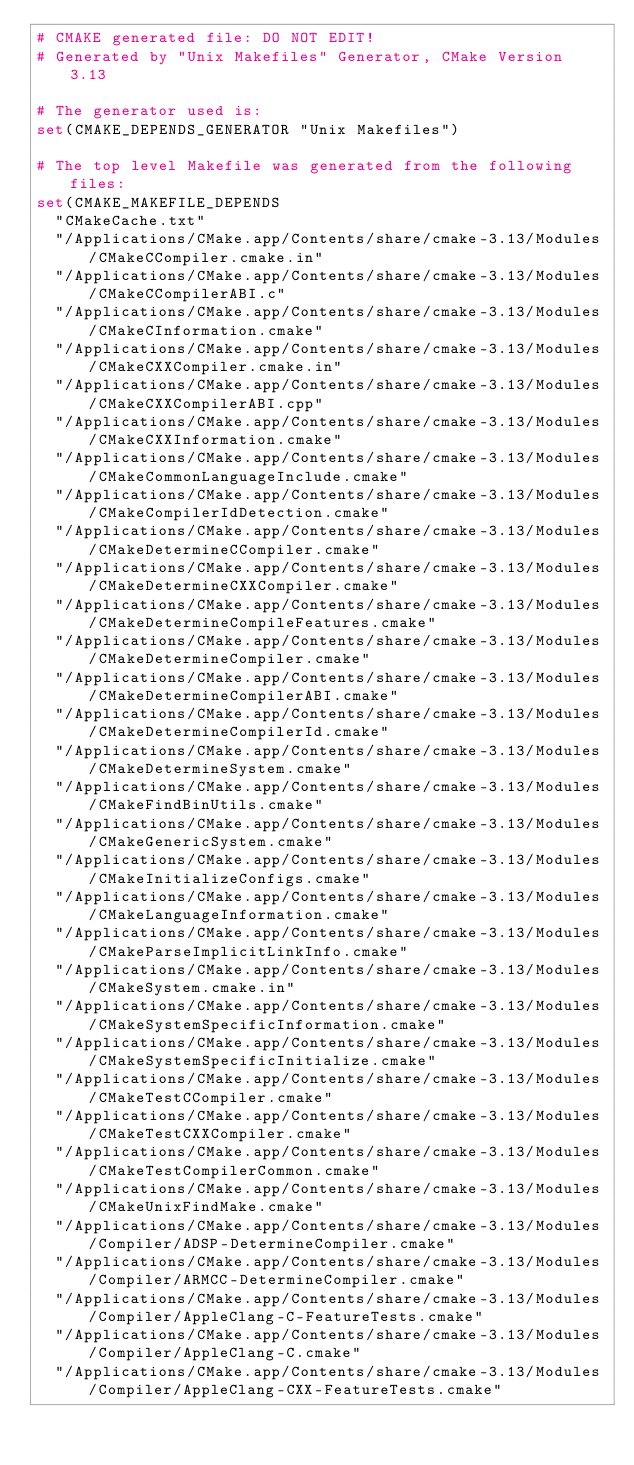Convert code to text. <code><loc_0><loc_0><loc_500><loc_500><_CMake_># CMAKE generated file: DO NOT EDIT!
# Generated by "Unix Makefiles" Generator, CMake Version 3.13

# The generator used is:
set(CMAKE_DEPENDS_GENERATOR "Unix Makefiles")

# The top level Makefile was generated from the following files:
set(CMAKE_MAKEFILE_DEPENDS
  "CMakeCache.txt"
  "/Applications/CMake.app/Contents/share/cmake-3.13/Modules/CMakeCCompiler.cmake.in"
  "/Applications/CMake.app/Contents/share/cmake-3.13/Modules/CMakeCCompilerABI.c"
  "/Applications/CMake.app/Contents/share/cmake-3.13/Modules/CMakeCInformation.cmake"
  "/Applications/CMake.app/Contents/share/cmake-3.13/Modules/CMakeCXXCompiler.cmake.in"
  "/Applications/CMake.app/Contents/share/cmake-3.13/Modules/CMakeCXXCompilerABI.cpp"
  "/Applications/CMake.app/Contents/share/cmake-3.13/Modules/CMakeCXXInformation.cmake"
  "/Applications/CMake.app/Contents/share/cmake-3.13/Modules/CMakeCommonLanguageInclude.cmake"
  "/Applications/CMake.app/Contents/share/cmake-3.13/Modules/CMakeCompilerIdDetection.cmake"
  "/Applications/CMake.app/Contents/share/cmake-3.13/Modules/CMakeDetermineCCompiler.cmake"
  "/Applications/CMake.app/Contents/share/cmake-3.13/Modules/CMakeDetermineCXXCompiler.cmake"
  "/Applications/CMake.app/Contents/share/cmake-3.13/Modules/CMakeDetermineCompileFeatures.cmake"
  "/Applications/CMake.app/Contents/share/cmake-3.13/Modules/CMakeDetermineCompiler.cmake"
  "/Applications/CMake.app/Contents/share/cmake-3.13/Modules/CMakeDetermineCompilerABI.cmake"
  "/Applications/CMake.app/Contents/share/cmake-3.13/Modules/CMakeDetermineCompilerId.cmake"
  "/Applications/CMake.app/Contents/share/cmake-3.13/Modules/CMakeDetermineSystem.cmake"
  "/Applications/CMake.app/Contents/share/cmake-3.13/Modules/CMakeFindBinUtils.cmake"
  "/Applications/CMake.app/Contents/share/cmake-3.13/Modules/CMakeGenericSystem.cmake"
  "/Applications/CMake.app/Contents/share/cmake-3.13/Modules/CMakeInitializeConfigs.cmake"
  "/Applications/CMake.app/Contents/share/cmake-3.13/Modules/CMakeLanguageInformation.cmake"
  "/Applications/CMake.app/Contents/share/cmake-3.13/Modules/CMakeParseImplicitLinkInfo.cmake"
  "/Applications/CMake.app/Contents/share/cmake-3.13/Modules/CMakeSystem.cmake.in"
  "/Applications/CMake.app/Contents/share/cmake-3.13/Modules/CMakeSystemSpecificInformation.cmake"
  "/Applications/CMake.app/Contents/share/cmake-3.13/Modules/CMakeSystemSpecificInitialize.cmake"
  "/Applications/CMake.app/Contents/share/cmake-3.13/Modules/CMakeTestCCompiler.cmake"
  "/Applications/CMake.app/Contents/share/cmake-3.13/Modules/CMakeTestCXXCompiler.cmake"
  "/Applications/CMake.app/Contents/share/cmake-3.13/Modules/CMakeTestCompilerCommon.cmake"
  "/Applications/CMake.app/Contents/share/cmake-3.13/Modules/CMakeUnixFindMake.cmake"
  "/Applications/CMake.app/Contents/share/cmake-3.13/Modules/Compiler/ADSP-DetermineCompiler.cmake"
  "/Applications/CMake.app/Contents/share/cmake-3.13/Modules/Compiler/ARMCC-DetermineCompiler.cmake"
  "/Applications/CMake.app/Contents/share/cmake-3.13/Modules/Compiler/AppleClang-C-FeatureTests.cmake"
  "/Applications/CMake.app/Contents/share/cmake-3.13/Modules/Compiler/AppleClang-C.cmake"
  "/Applications/CMake.app/Contents/share/cmake-3.13/Modules/Compiler/AppleClang-CXX-FeatureTests.cmake"</code> 